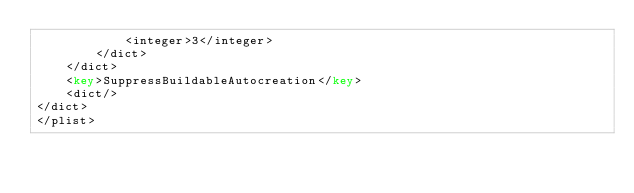<code> <loc_0><loc_0><loc_500><loc_500><_XML_>			<integer>3</integer>
		</dict>
	</dict>
	<key>SuppressBuildableAutocreation</key>
	<dict/>
</dict>
</plist>
</code> 